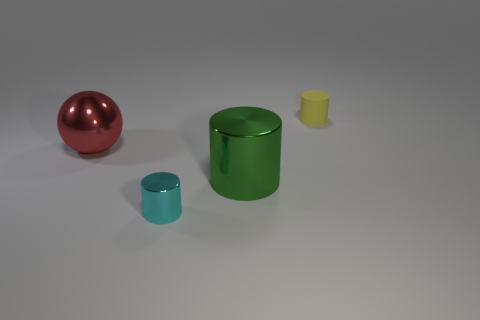There is a shiny thing that is both on the left side of the green thing and in front of the red shiny object; what shape is it?
Your answer should be very brief. Cylinder. What is the color of the tiny cylinder in front of the small yellow matte cylinder?
Ensure brevity in your answer.  Cyan. How big is the thing that is behind the big metal cylinder and to the right of the cyan metal object?
Ensure brevity in your answer.  Small. Does the red sphere have the same material as the cylinder that is behind the shiny sphere?
Offer a very short reply. No. What number of small yellow things have the same shape as the big green shiny object?
Offer a very short reply. 1. How many metal cylinders are there?
Ensure brevity in your answer.  2. Is the shape of the green metal object the same as the metallic thing in front of the green metallic object?
Keep it short and to the point. Yes. What number of objects are either metallic blocks or green objects in front of the large red sphere?
Give a very brief answer. 1. What is the material of the green object that is the same shape as the yellow thing?
Ensure brevity in your answer.  Metal. There is a tiny thing to the left of the matte cylinder; does it have the same shape as the green object?
Your response must be concise. Yes. 